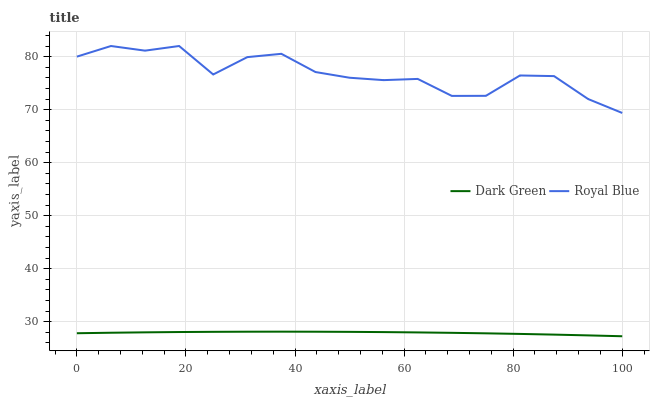Does Dark Green have the minimum area under the curve?
Answer yes or no. Yes. Does Royal Blue have the maximum area under the curve?
Answer yes or no. Yes. Does Dark Green have the maximum area under the curve?
Answer yes or no. No. Is Dark Green the smoothest?
Answer yes or no. Yes. Is Royal Blue the roughest?
Answer yes or no. Yes. Is Dark Green the roughest?
Answer yes or no. No. Does Dark Green have the lowest value?
Answer yes or no. Yes. Does Royal Blue have the highest value?
Answer yes or no. Yes. Does Dark Green have the highest value?
Answer yes or no. No. Is Dark Green less than Royal Blue?
Answer yes or no. Yes. Is Royal Blue greater than Dark Green?
Answer yes or no. Yes. Does Dark Green intersect Royal Blue?
Answer yes or no. No. 